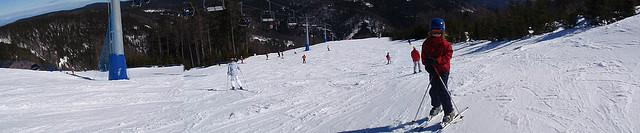What is a term used for this place?

Choices:
A) first base
B) grapes
C) hoop
D) downhill downhill 